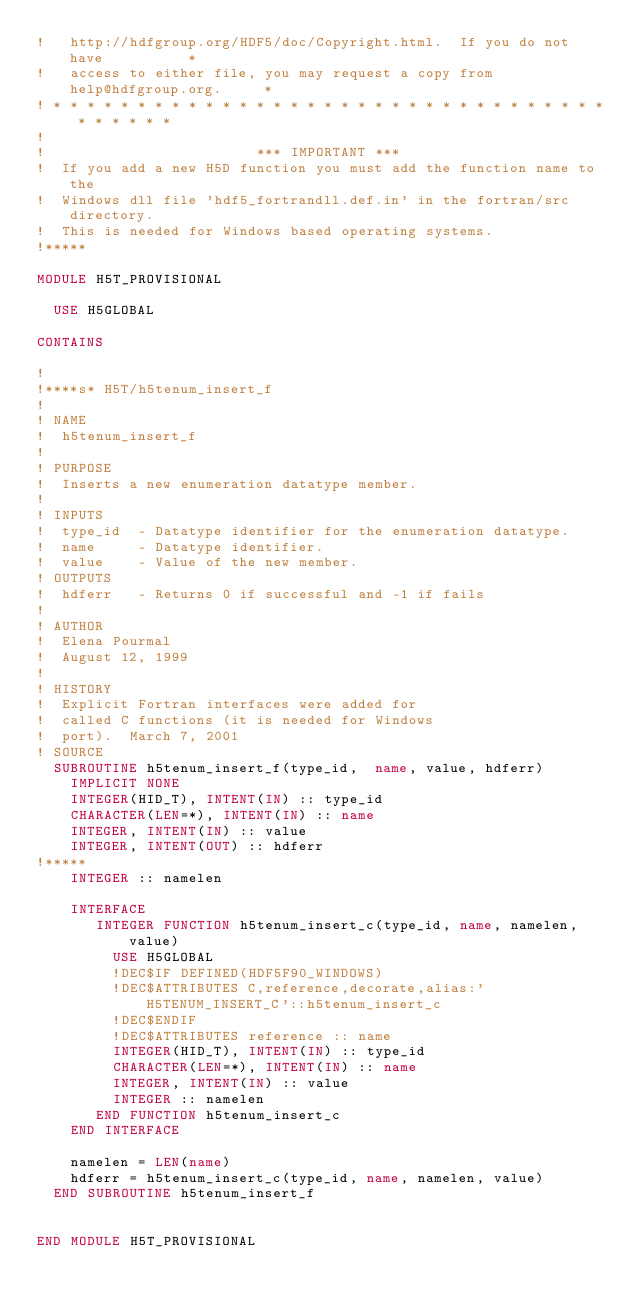<code> <loc_0><loc_0><loc_500><loc_500><_FORTRAN_>!   http://hdfgroup.org/HDF5/doc/Copyright.html.  If you do not have          *
!   access to either file, you may request a copy from help@hdfgroup.org.     *
! * * * * * * * * * * * * * * * * * * * * * * * * * * * * * * * * * * * * * * *
!
!                         *** IMPORTANT ***
!  If you add a new H5D function you must add the function name to the
!  Windows dll file 'hdf5_fortrandll.def.in' in the fortran/src directory.
!  This is needed for Windows based operating systems.
!*****

MODULE H5T_PROVISIONAL

  USE H5GLOBAL

CONTAINS

!
!****s* H5T/h5tenum_insert_f
!
! NAME
!  h5tenum_insert_f
!
! PURPOSE
!  Inserts a new enumeration datatype member.
!
! INPUTS
!  type_id  - Datatype identifier for the enumeration datatype.
!  name     - Datatype identifier.
!  value    - Value of the new member.
! OUTPUTS
!  hdferr   - Returns 0 if successful and -1 if fails
!
! AUTHOR
!  Elena Pourmal
!  August 12, 1999
!
! HISTORY
!  Explicit Fortran interfaces were added for
!  called C functions (it is needed for Windows
!  port).  March 7, 2001
! SOURCE
  SUBROUTINE h5tenum_insert_f(type_id,  name, value, hdferr)
    IMPLICIT NONE
    INTEGER(HID_T), INTENT(IN) :: type_id
    CHARACTER(LEN=*), INTENT(IN) :: name
    INTEGER, INTENT(IN) :: value
    INTEGER, INTENT(OUT) :: hdferr
!*****
    INTEGER :: namelen
    
    INTERFACE
       INTEGER FUNCTION h5tenum_insert_c(type_id, name, namelen, value)
         USE H5GLOBAL
         !DEC$IF DEFINED(HDF5F90_WINDOWS)
         !DEC$ATTRIBUTES C,reference,decorate,alias:'H5TENUM_INSERT_C'::h5tenum_insert_c
         !DEC$ENDIF
         !DEC$ATTRIBUTES reference :: name
         INTEGER(HID_T), INTENT(IN) :: type_id
         CHARACTER(LEN=*), INTENT(IN) :: name
         INTEGER, INTENT(IN) :: value
         INTEGER :: namelen
       END FUNCTION h5tenum_insert_c
    END INTERFACE
    
    namelen = LEN(name)
    hdferr = h5tenum_insert_c(type_id, name, namelen, value)
  END SUBROUTINE h5tenum_insert_f
  

END MODULE H5T_PROVISIONAL
</code> 